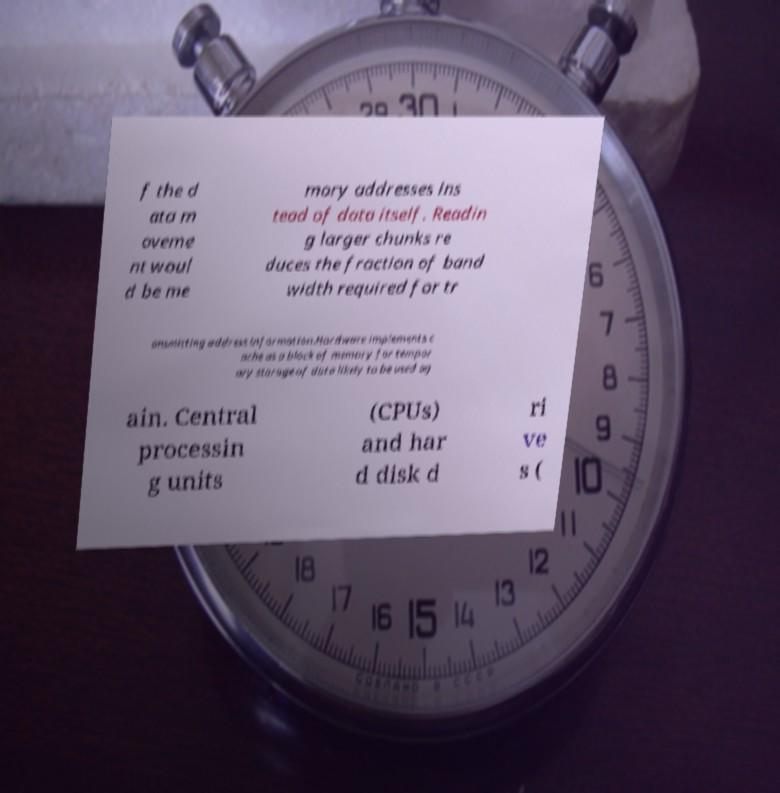Could you extract and type out the text from this image? f the d ata m oveme nt woul d be me mory addresses ins tead of data itself. Readin g larger chunks re duces the fraction of band width required for tr ansmitting address information.Hardware implements c ache as a block of memory for tempor ary storage of data likely to be used ag ain. Central processin g units (CPUs) and har d disk d ri ve s ( 